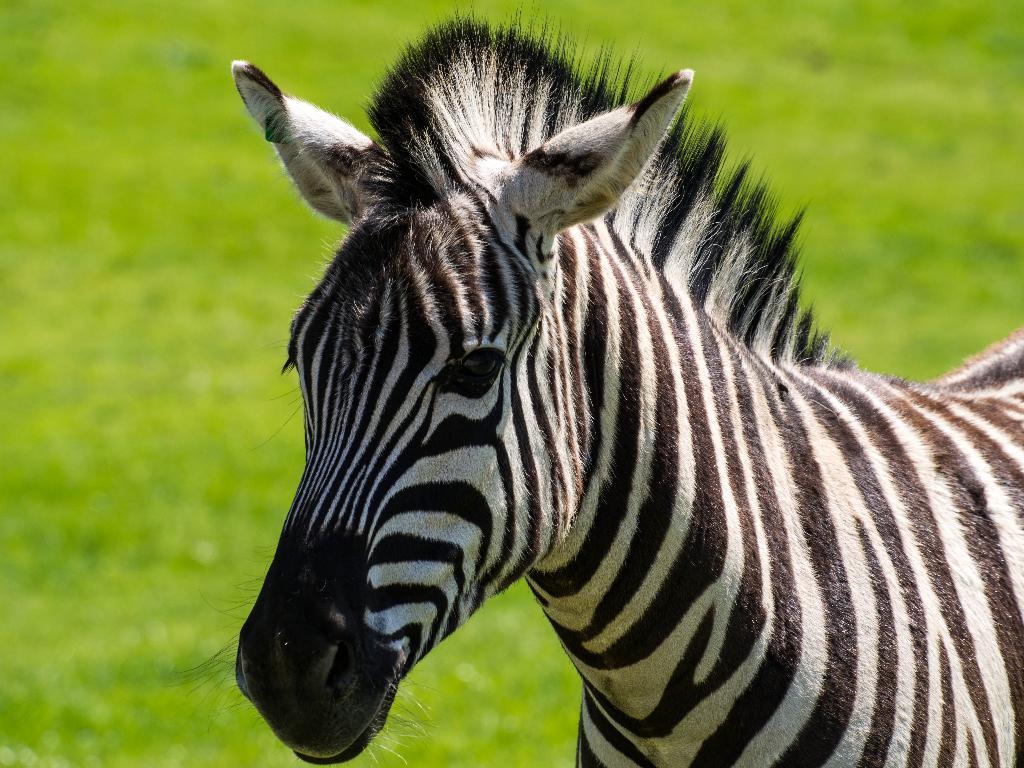Could you give a brief overview of what you see in this image? In this picture we can see a zebra standing in the front, at the bottom there is grass. 